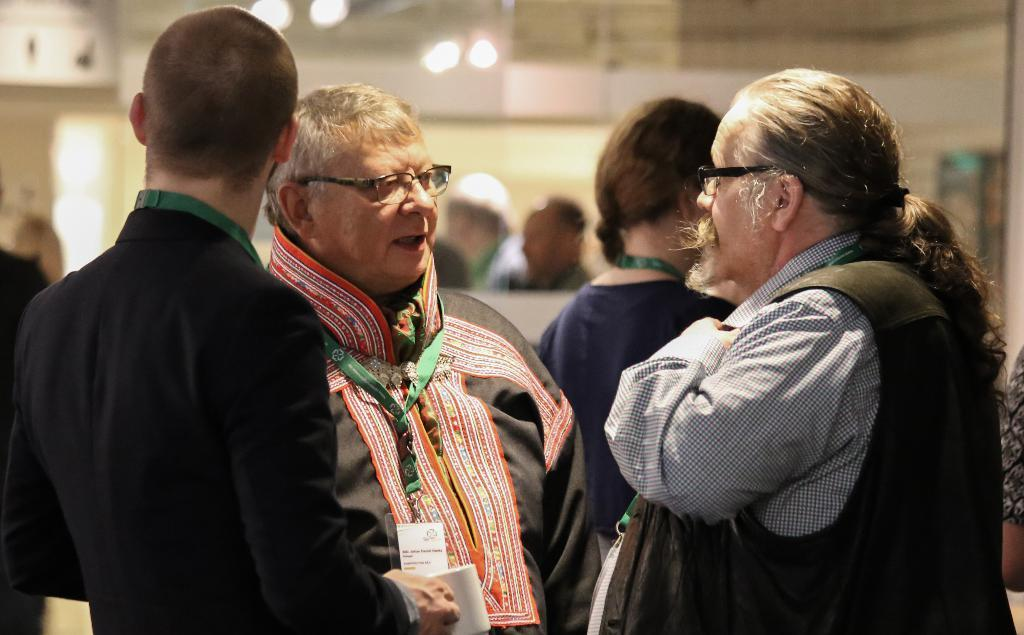What is the main subject of the image? The main subject of the image is a group of people. Can you describe what one of the people is holding? Yes, a man is holding a cup in the image. What type of structure can be seen in the background? There is a wall visible in the image. What can be seen providing illumination in the image? There are lights present in the image. How many people can someone join the line of people in the image? There is no line of people in the image; it features a group of people. What type of coast can be seen in the image? There is no coast present in the image. 